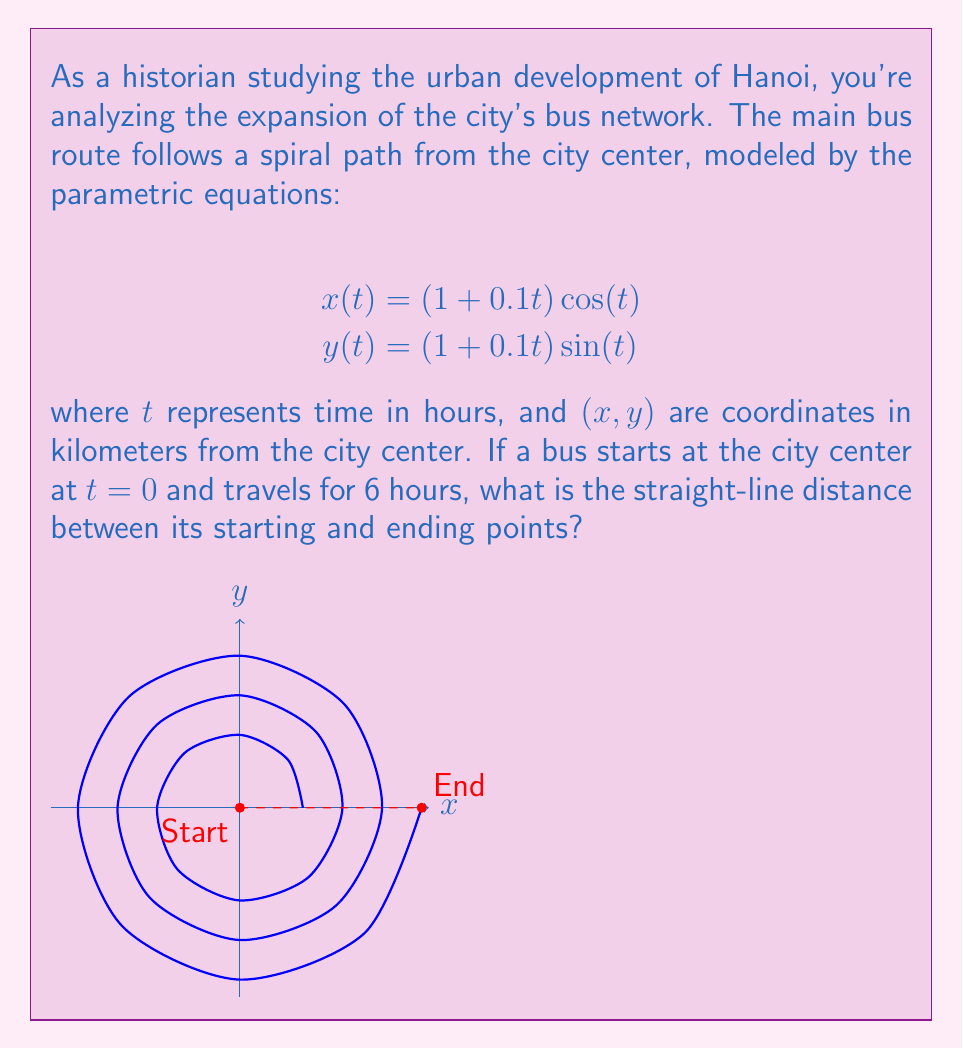Could you help me with this problem? Let's approach this step-by-step:

1) First, we need to find the coordinates of the end point after 6 hours. Since $t$ is in hours, we use $t = 6\pi$ (as $2\pi$ represents one full rotation, which takes 1 hour).

2) For the end point:
   $$x(6\pi) = (1 + 0.1(6\pi)) \cos(6\pi) = (1 + 0.6\pi) \cdot 1 = 1 + 0.6\pi$$
   $$y(6\pi) = (1 + 0.1(6\pi)) \sin(6\pi) = (1 + 0.6\pi) \cdot 0 = 0$$

3) The starting point is at the origin (0, 0).

4) To find the straight-line distance, we can use the distance formula:
   $$d = \sqrt{(x_2 - x_1)^2 + (y_2 - y_1)^2}$$

5) Plugging in our values:
   $$d = \sqrt{((1 + 0.6\pi) - 0)^2 + (0 - 0)^2}$$

6) Simplifying:
   $$d = \sqrt{(1 + 0.6\pi)^2} = 1 + 0.6\pi$$

7) This gives us the distance in kilometers.
Answer: $1 + 0.6\pi$ km 